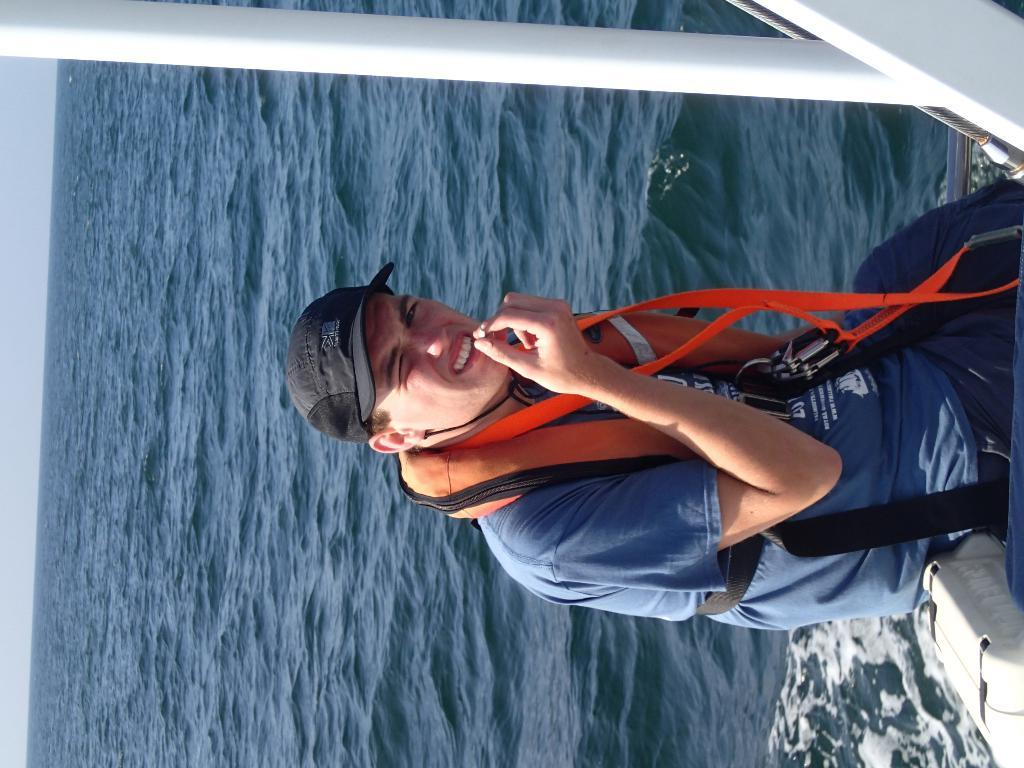What is the person in the image doing? There is a person sitting in a ship in the image. What type of clothing is the person wearing on their head? The person is wearing a black cap. What type of clothing is the person wearing for safety purposes? The person is wearing a safety jacket. What can be seen in the background of the image? There is water visible in the image. What type of bed is visible in the image? There is no bed present in the image; it features a person sitting in a ship. What emotion does the person appear to be experiencing in the image? The image does not convey any specific emotion or fear. 